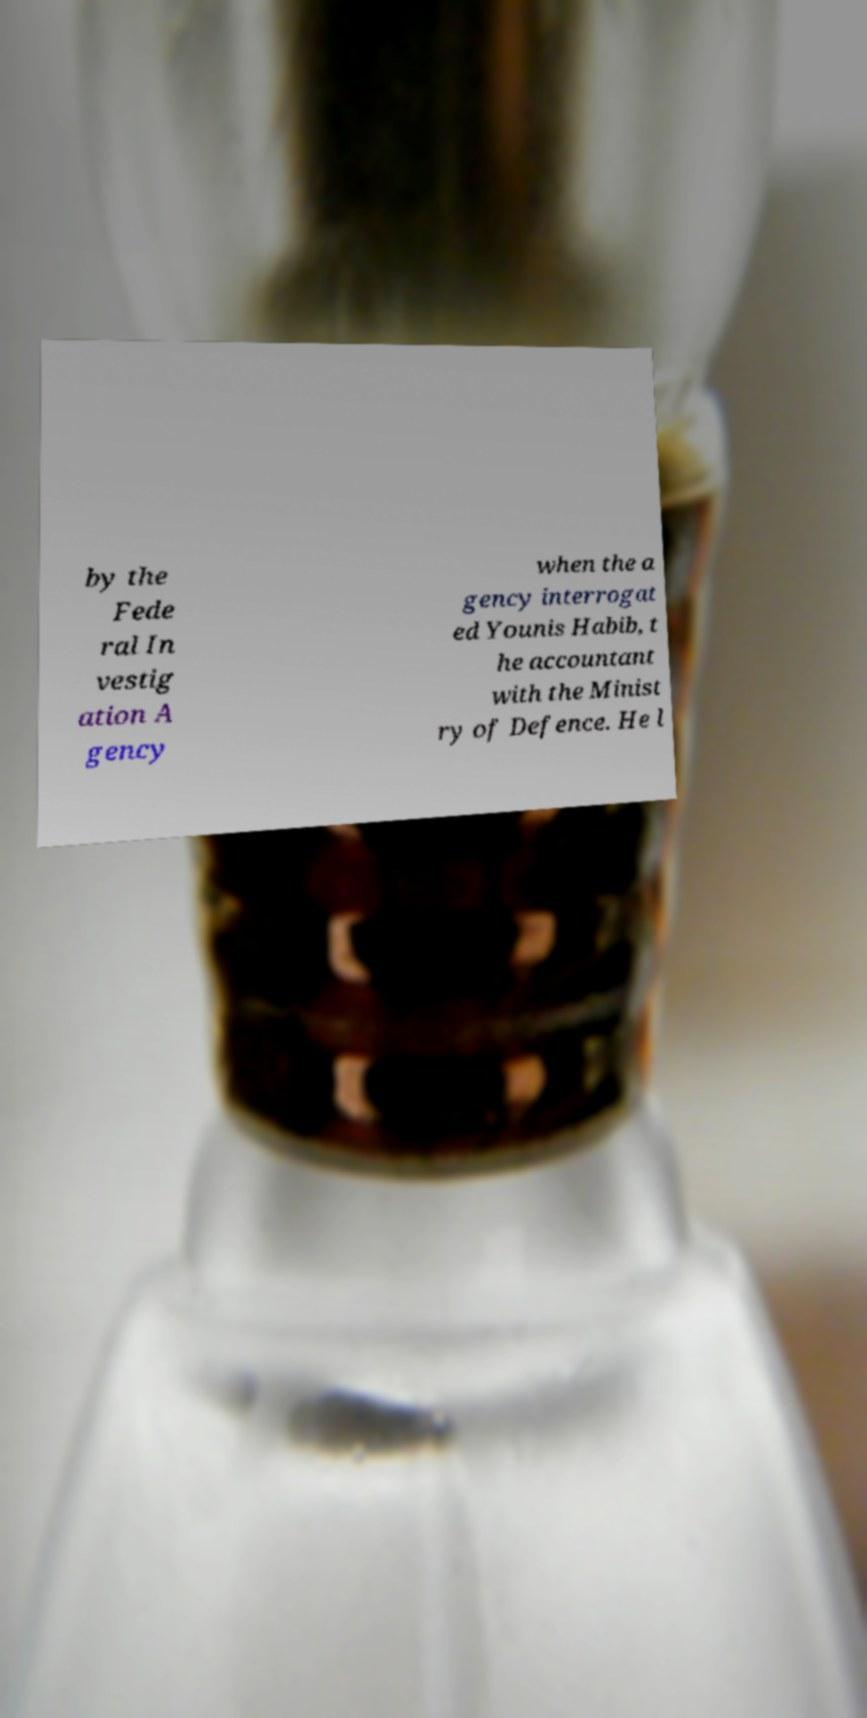Can you read and provide the text displayed in the image?This photo seems to have some interesting text. Can you extract and type it out for me? by the Fede ral In vestig ation A gency when the a gency interrogat ed Younis Habib, t he accountant with the Minist ry of Defence. He l 